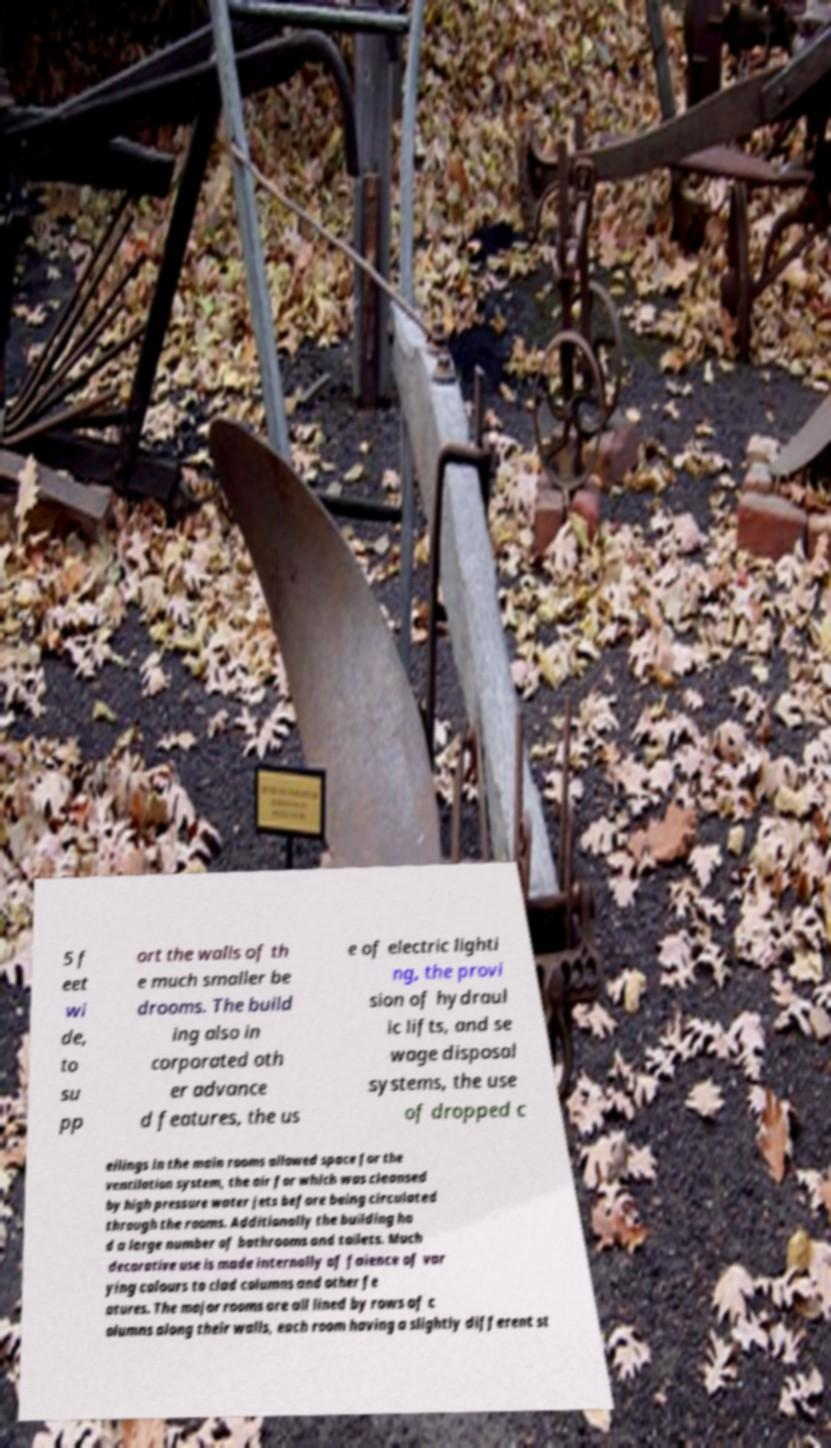Please identify and transcribe the text found in this image. 5 f eet wi de, to su pp ort the walls of th e much smaller be drooms. The build ing also in corporated oth er advance d features, the us e of electric lighti ng, the provi sion of hydraul ic lifts, and se wage disposal systems, the use of dropped c eilings in the main rooms allowed space for the ventilation system, the air for which was cleansed by high pressure water jets before being circulated through the rooms. Additionally the building ha d a large number of bathrooms and toilets. Much decorative use is made internally of faience of var ying colours to clad columns and other fe atures. The major rooms are all lined by rows of c olumns along their walls, each room having a slightly different st 